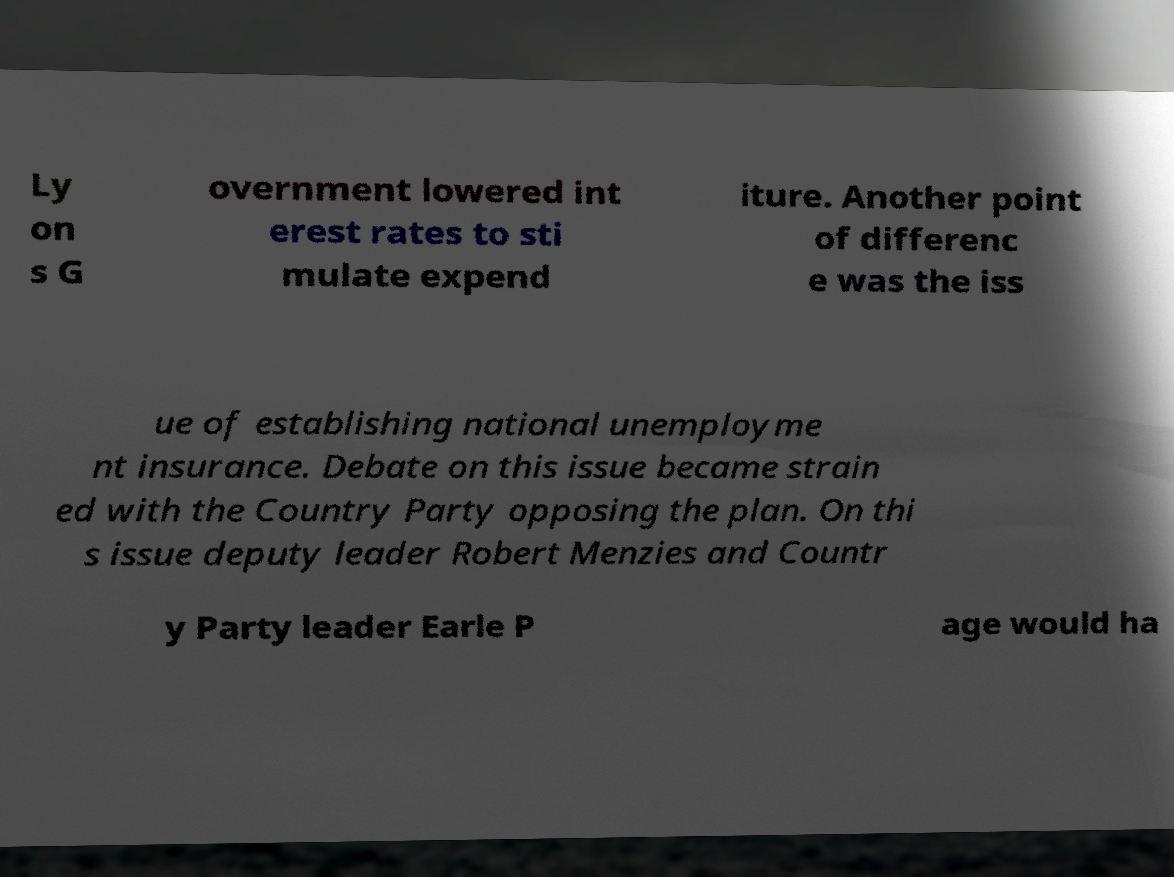What messages or text are displayed in this image? I need them in a readable, typed format. Ly on s G overnment lowered int erest rates to sti mulate expend iture. Another point of differenc e was the iss ue of establishing national unemployme nt insurance. Debate on this issue became strain ed with the Country Party opposing the plan. On thi s issue deputy leader Robert Menzies and Countr y Party leader Earle P age would ha 